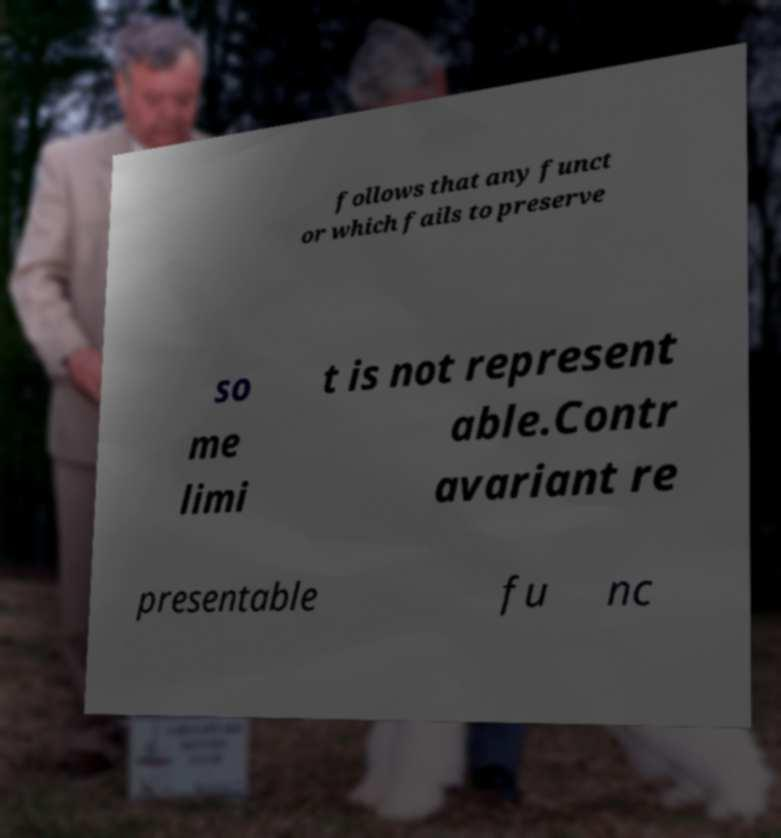There's text embedded in this image that I need extracted. Can you transcribe it verbatim? follows that any funct or which fails to preserve so me limi t is not represent able.Contr avariant re presentable fu nc 